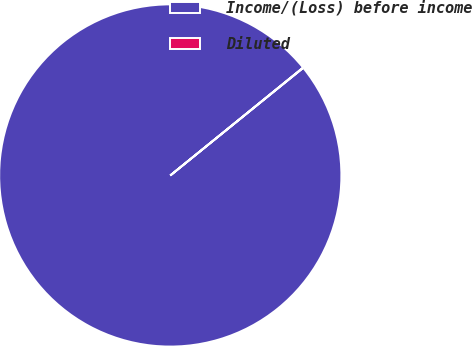Convert chart to OTSL. <chart><loc_0><loc_0><loc_500><loc_500><pie_chart><fcel>Income/(Loss) before income<fcel>Diluted<nl><fcel>99.97%<fcel>0.03%<nl></chart> 